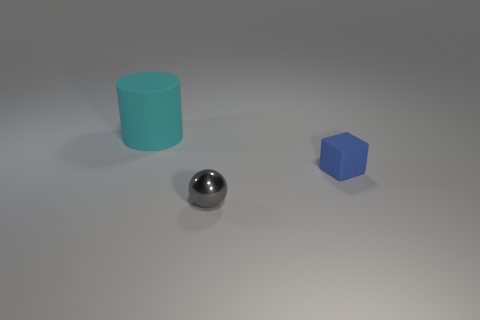How many other tiny objects are the same shape as the blue thing?
Your answer should be compact. 0. Is the size of the matte thing left of the blue matte object the same as the thing in front of the small blue block?
Offer a very short reply. No. What shape is the rubber object to the right of the rubber object on the left side of the small cube?
Ensure brevity in your answer.  Cube. Is the number of gray metal things in front of the tiny metallic object the same as the number of big cyan rubber objects?
Make the answer very short. No. The tiny thing behind the small object that is to the left of the matte object in front of the big cyan object is made of what material?
Give a very brief answer. Rubber. Are there any other cubes of the same size as the blue block?
Keep it short and to the point. No. What is the shape of the tiny metallic thing?
Offer a very short reply. Sphere. How many blocks are either cyan objects or small purple things?
Offer a terse response. 0. Are there an equal number of big cyan rubber things that are behind the rubber block and small blue rubber objects that are on the left side of the tiny gray sphere?
Your answer should be very brief. No. There is a cyan thing behind the tiny object in front of the blue matte object; what number of tiny gray objects are behind it?
Provide a succinct answer. 0. 